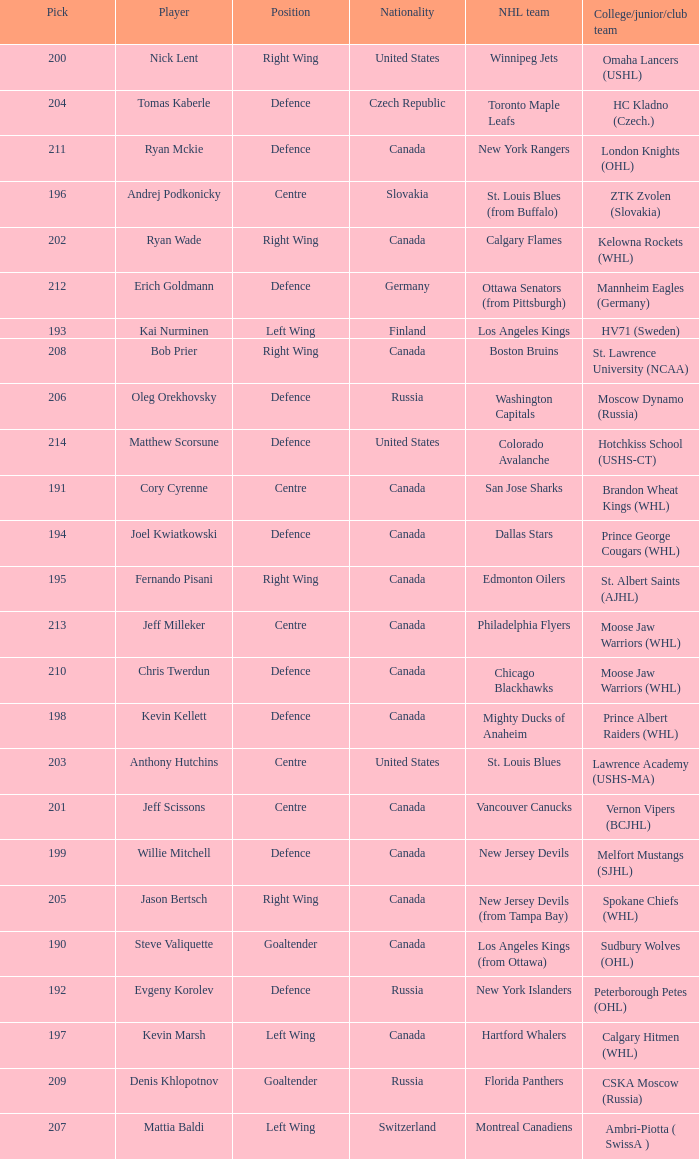Name the college for andrej podkonicky ZTK Zvolen (Slovakia). 